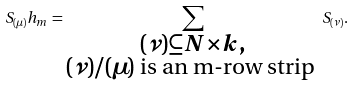<formula> <loc_0><loc_0><loc_500><loc_500>S _ { ( \mu ) } h _ { m } = \sum _ { \substack { ( \nu ) \subseteq { N \times k } , \\ ( \nu ) / ( \mu ) \text { is an m-row strip } } } S _ { ( \nu ) } .</formula> 